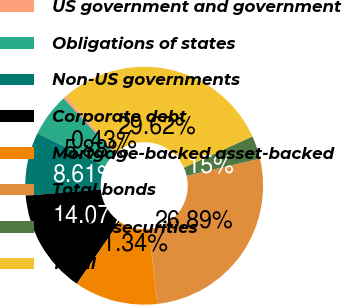Convert chart to OTSL. <chart><loc_0><loc_0><loc_500><loc_500><pie_chart><fcel>US government and government<fcel>Obligations of states<fcel>Non-US governments<fcel>Corporate debt<fcel>Mortgage-backed asset-backed<fcel>Total bonds<fcel>Equity securities<fcel>Total<nl><fcel>0.43%<fcel>5.88%<fcel>8.61%<fcel>14.07%<fcel>11.34%<fcel>26.89%<fcel>3.15%<fcel>29.62%<nl></chart> 